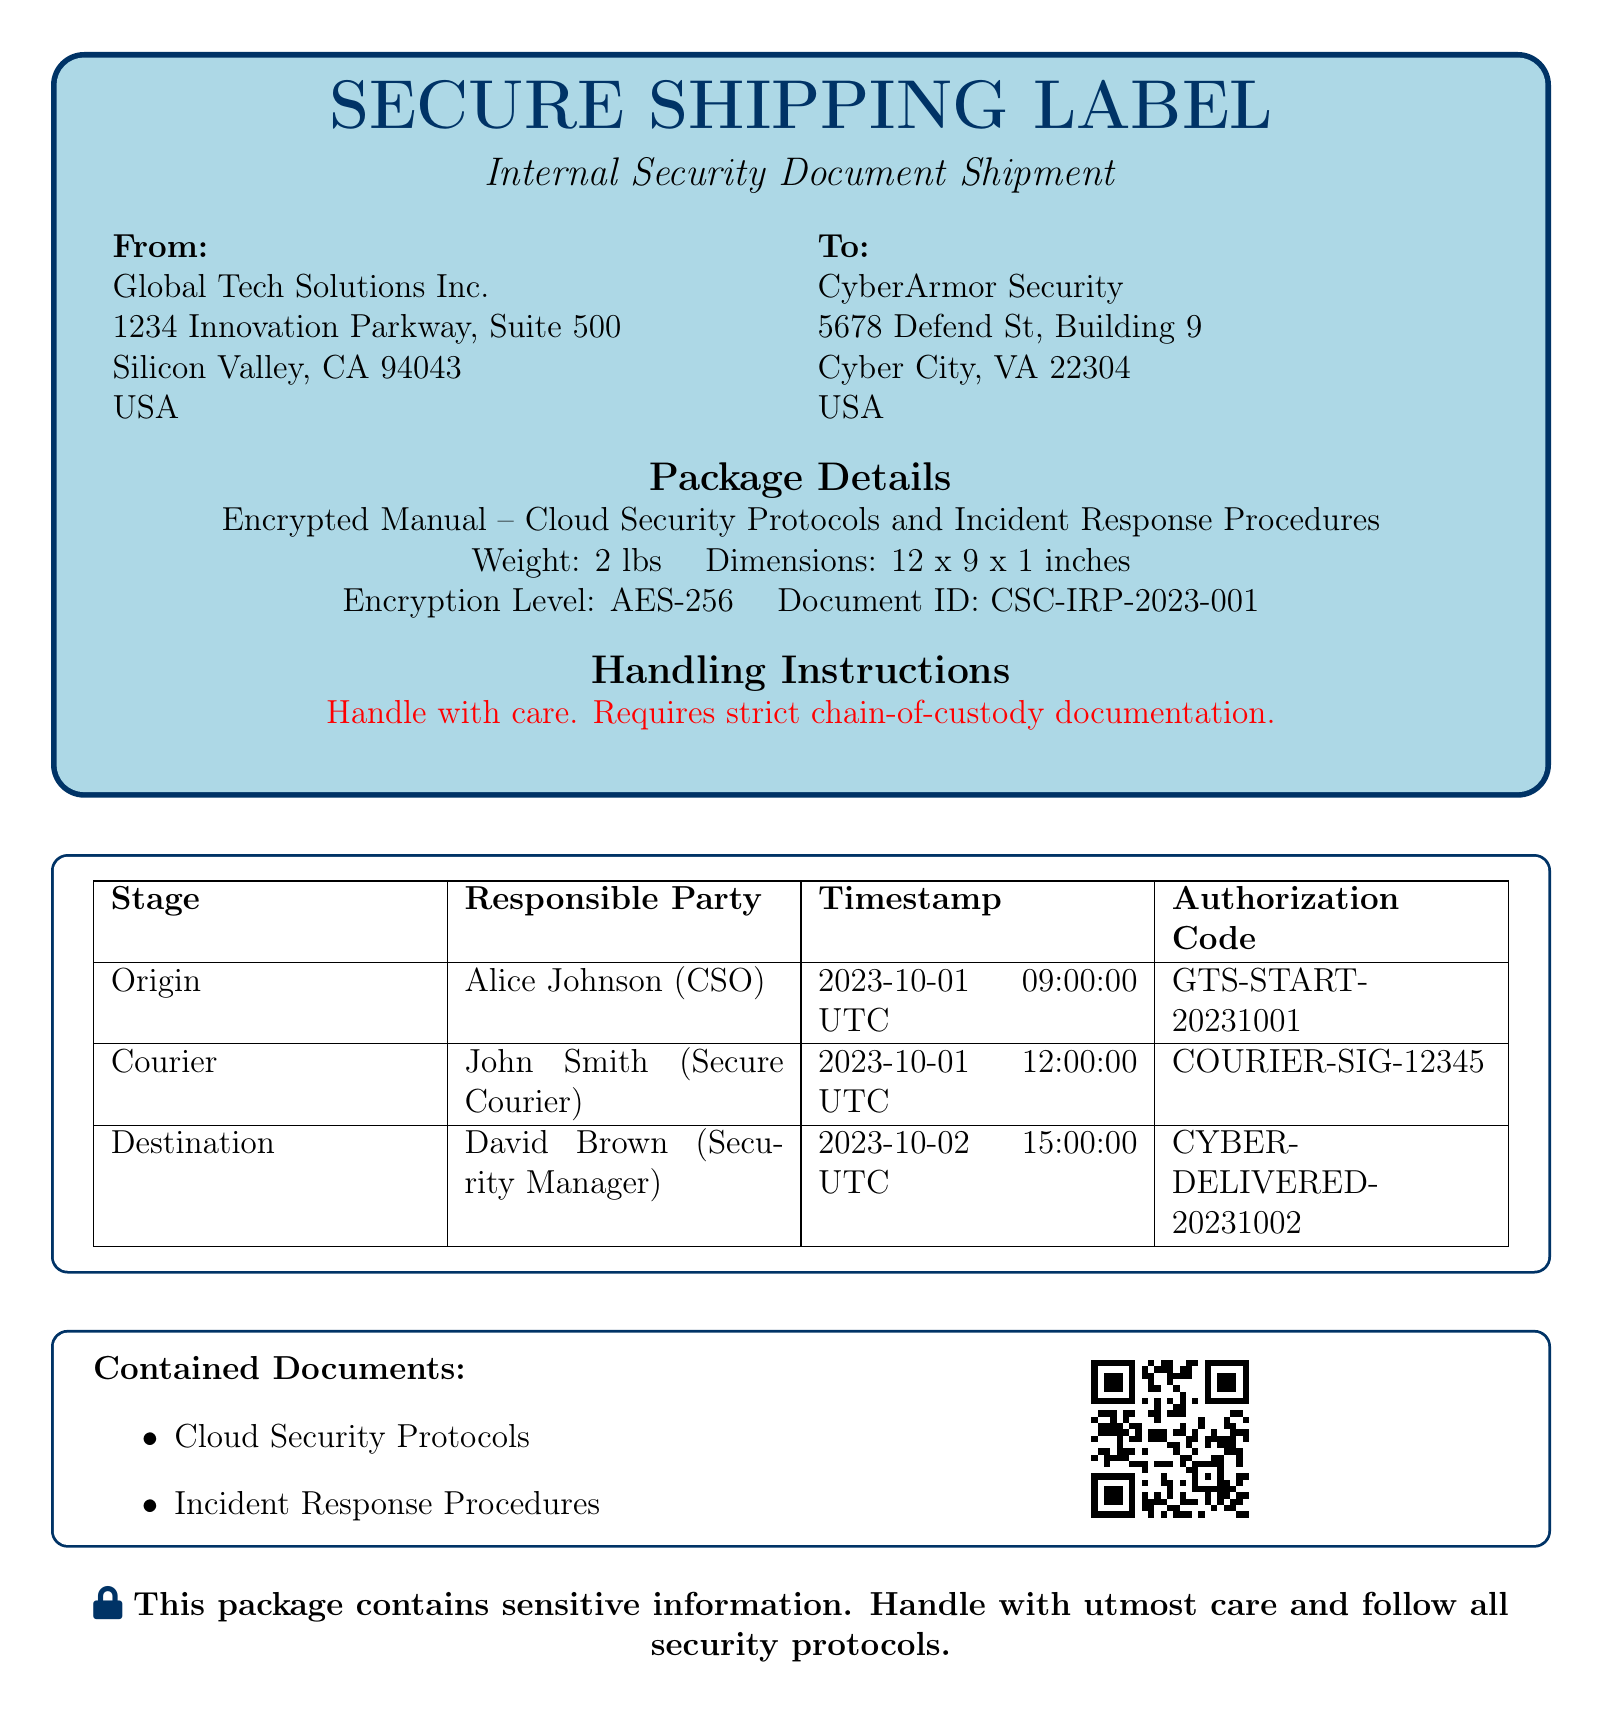What is the document ID? The document ID is listed in the package details section of the shipping label.
Answer: CSC-IRP-2023-001 Who is the sender of the document? The sender's information is provided in the 'From' section of the shipping label.
Answer: Global Tech Solutions Inc What is the encryption level used for this document? The encryption level is specified in the package details of the shipping label.
Answer: AES-256 When was the package delivered to the destination? The timestamp for the delivery is in the stage detail table under 'Destination'.
Answer: 2023-10-02 15:00:00 UTC What is the weight of the package? The package weight is found in the package details section of the shipping label.
Answer: 2 lbs What is required for the handling of this document? The handling instructions clearly state what is needed for this document.
Answer: Strict chain-of-custody documentation Who is responsible for the origin stage of the shipment? The responsible party for the origin stage is mentioned in the stage detail table.
Answer: Alice Johnson (CSO) What type of documents are contained in the shipment? The types of documents contained are listed in the 'Contained Documents' section.
Answer: Cloud Security Protocols, Incident Response Procedures What color is used for the box background in the shipping label? The color used for the box background is specified in the tcolorbox settings.
Answer: Light blue 